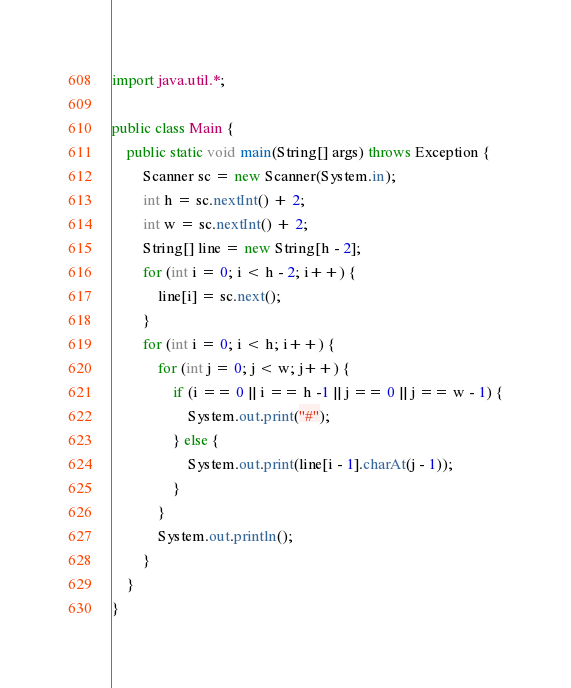<code> <loc_0><loc_0><loc_500><loc_500><_Java_>import java.util.*;

public class Main {
    public static void main(String[] args) throws Exception {
        Scanner sc = new Scanner(System.in);
        int h = sc.nextInt() + 2;
        int w = sc.nextInt() + 2;
        String[] line = new String[h - 2];
        for (int i = 0; i < h - 2; i++) {
            line[i] = sc.next();
        }
        for (int i = 0; i < h; i++) {
            for (int j = 0; j < w; j++) {
                if (i == 0 || i == h -1 || j == 0 || j == w - 1) {
                    System.out.print("#");
                } else {
                    System.out.print(line[i - 1].charAt(j - 1));
                }
            }
            System.out.println();
        }
    }
}
</code> 